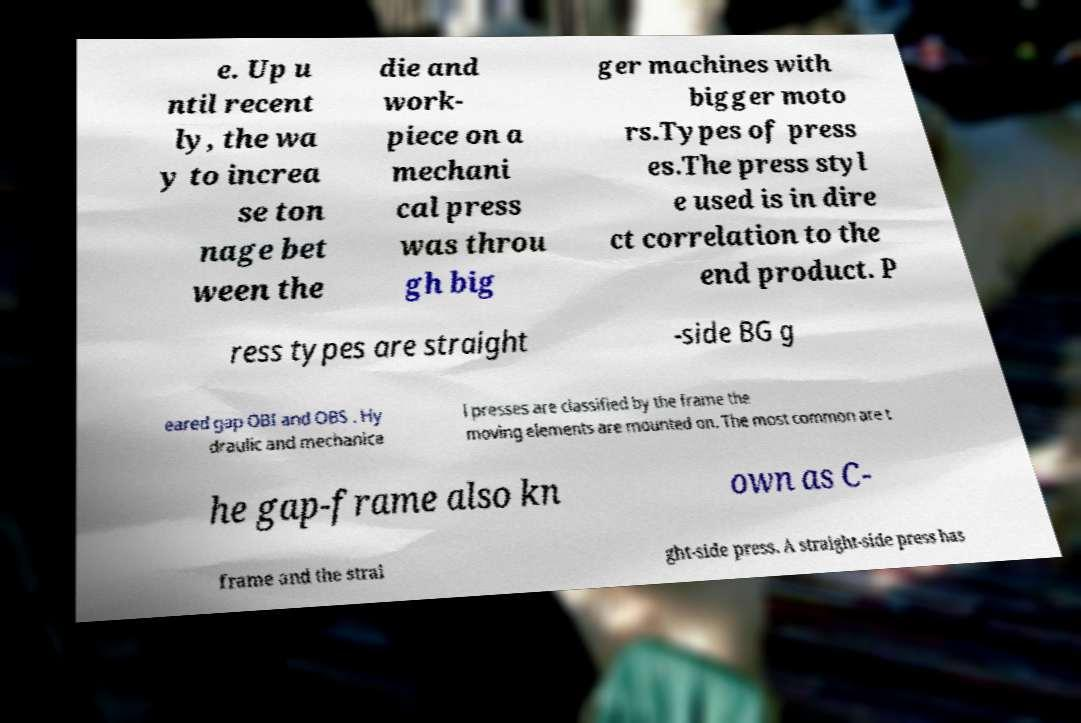Could you extract and type out the text from this image? e. Up u ntil recent ly, the wa y to increa se ton nage bet ween the die and work- piece on a mechani cal press was throu gh big ger machines with bigger moto rs.Types of press es.The press styl e used is in dire ct correlation to the end product. P ress types are straight -side BG g eared gap OBI and OBS . Hy draulic and mechanica l presses are classified by the frame the moving elements are mounted on. The most common are t he gap-frame also kn own as C- frame and the strai ght-side press. A straight-side press has 